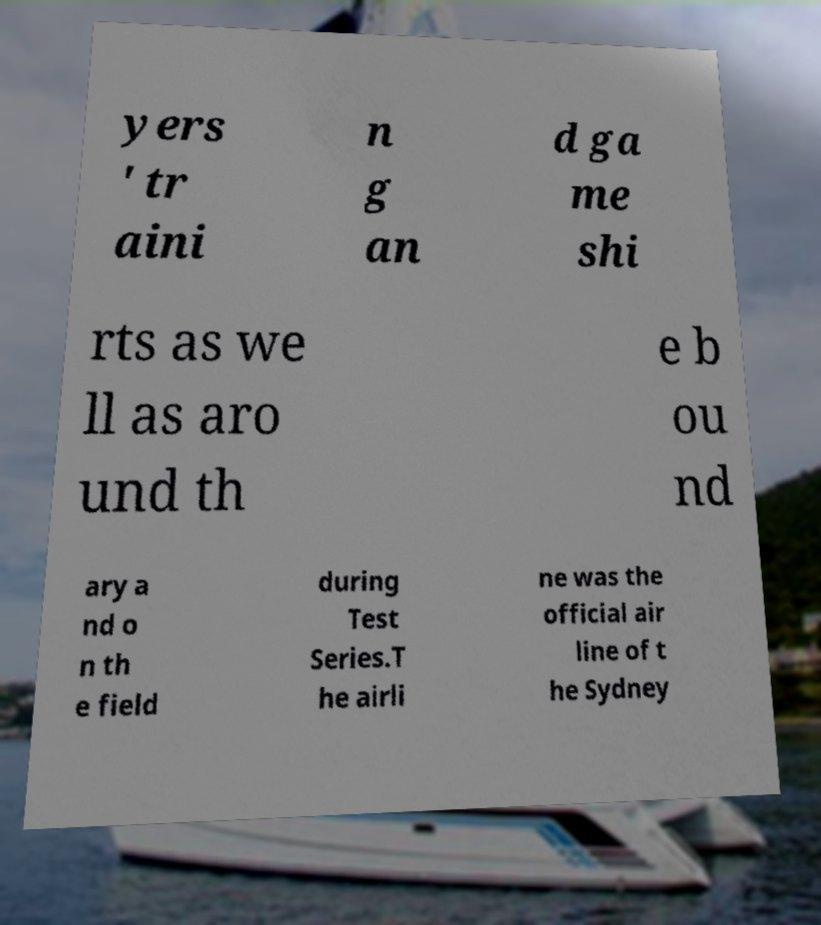Could you assist in decoding the text presented in this image and type it out clearly? yers ' tr aini n g an d ga me shi rts as we ll as aro und th e b ou nd ary a nd o n th e field during Test Series.T he airli ne was the official air line of t he Sydney 